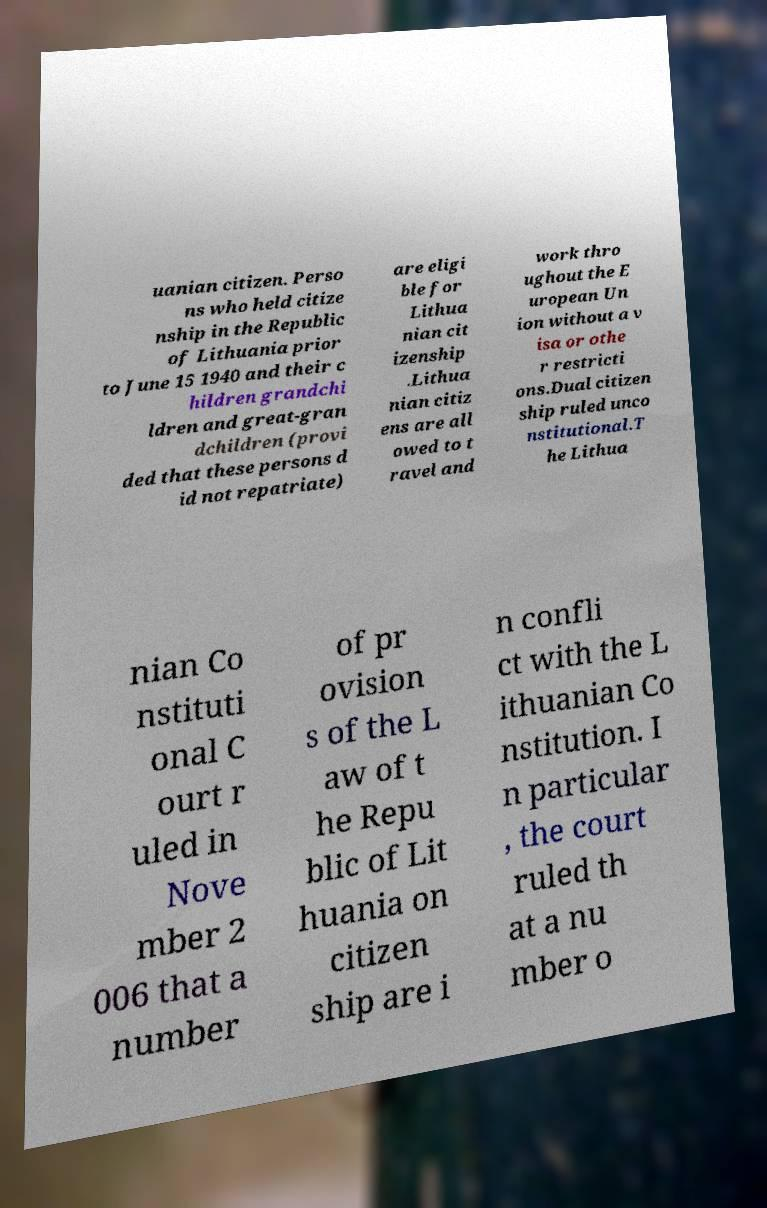Please read and relay the text visible in this image. What does it say? uanian citizen. Perso ns who held citize nship in the Republic of Lithuania prior to June 15 1940 and their c hildren grandchi ldren and great-gran dchildren (provi ded that these persons d id not repatriate) are eligi ble for Lithua nian cit izenship .Lithua nian citiz ens are all owed to t ravel and work thro ughout the E uropean Un ion without a v isa or othe r restricti ons.Dual citizen ship ruled unco nstitutional.T he Lithua nian Co nstituti onal C ourt r uled in Nove mber 2 006 that a number of pr ovision s of the L aw of t he Repu blic of Lit huania on citizen ship are i n confli ct with the L ithuanian Co nstitution. I n particular , the court ruled th at a nu mber o 